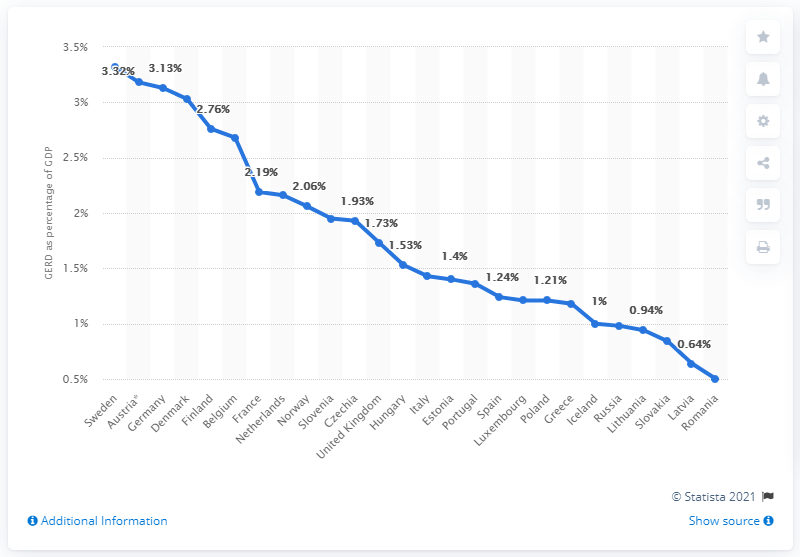Indicate a few pertinent items in this graphic. According to data from 2018, Romania was the country that spent the least amount of its GDP on research and development. According to data from 2018, Sweden was the country that spent the largest percentage of its Gross Domestic Product (GDP) on research and development. Specifically, Sweden spent 3.32% of its GDP on research and development in that year. 